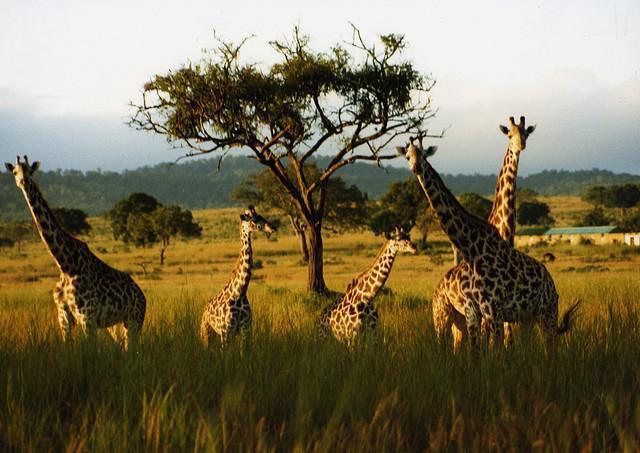How many giraffes are in the image?
Give a very brief answer. 5. How many giraffes are visible?
Give a very brief answer. 5. How many people are wearing a green hat?
Give a very brief answer. 0. 